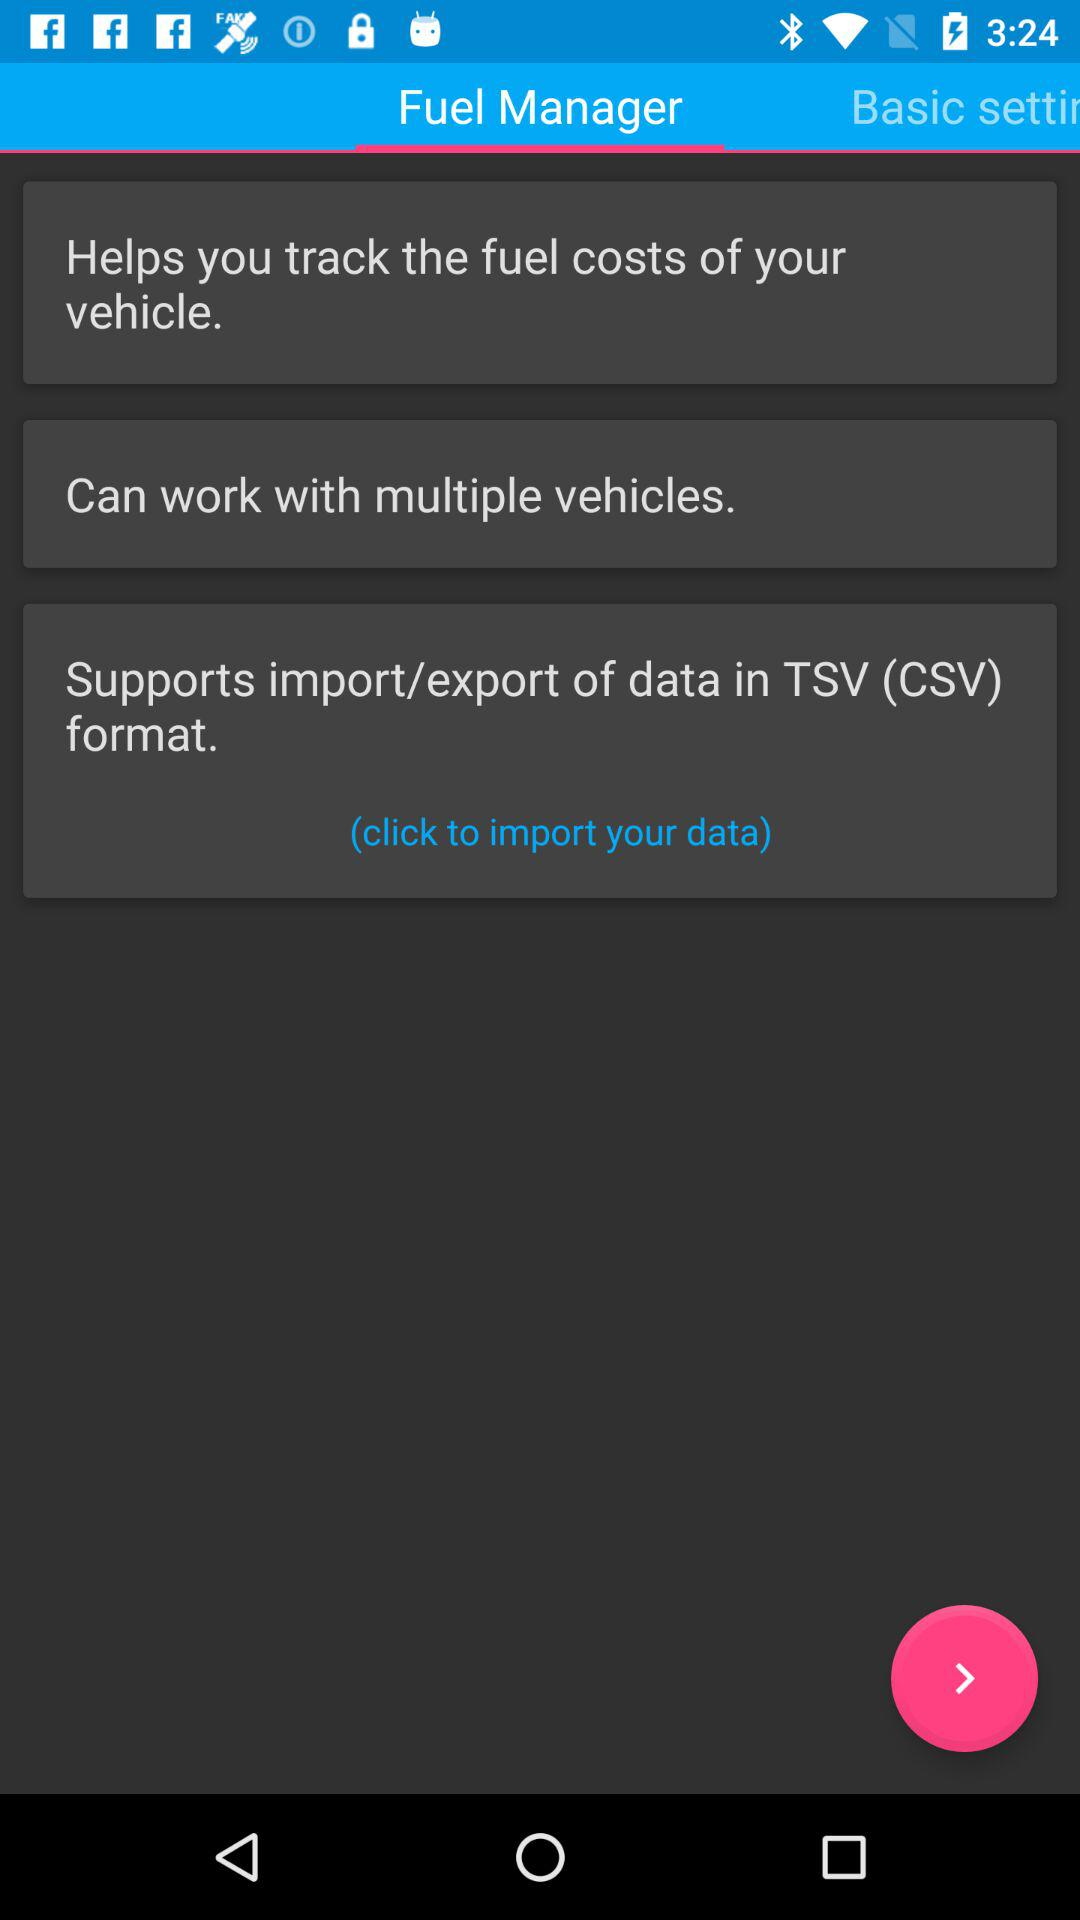Which tab is selected? The selected tab is "Fuel Manager". 